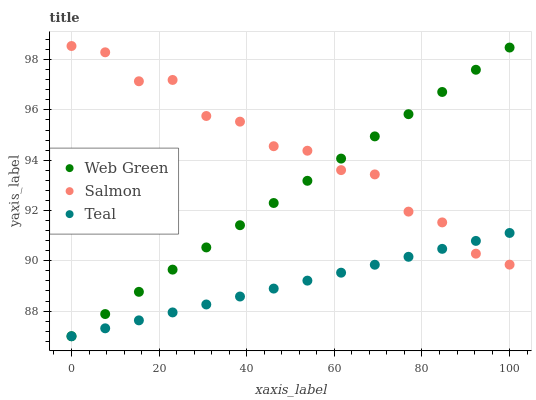Does Teal have the minimum area under the curve?
Answer yes or no. Yes. Does Salmon have the maximum area under the curve?
Answer yes or no. Yes. Does Web Green have the minimum area under the curve?
Answer yes or no. No. Does Web Green have the maximum area under the curve?
Answer yes or no. No. Is Teal the smoothest?
Answer yes or no. Yes. Is Salmon the roughest?
Answer yes or no. Yes. Is Web Green the smoothest?
Answer yes or no. No. Is Web Green the roughest?
Answer yes or no. No. Does Teal have the lowest value?
Answer yes or no. Yes. Does Salmon have the highest value?
Answer yes or no. Yes. Does Web Green have the highest value?
Answer yes or no. No. Does Teal intersect Salmon?
Answer yes or no. Yes. Is Teal less than Salmon?
Answer yes or no. No. Is Teal greater than Salmon?
Answer yes or no. No. 